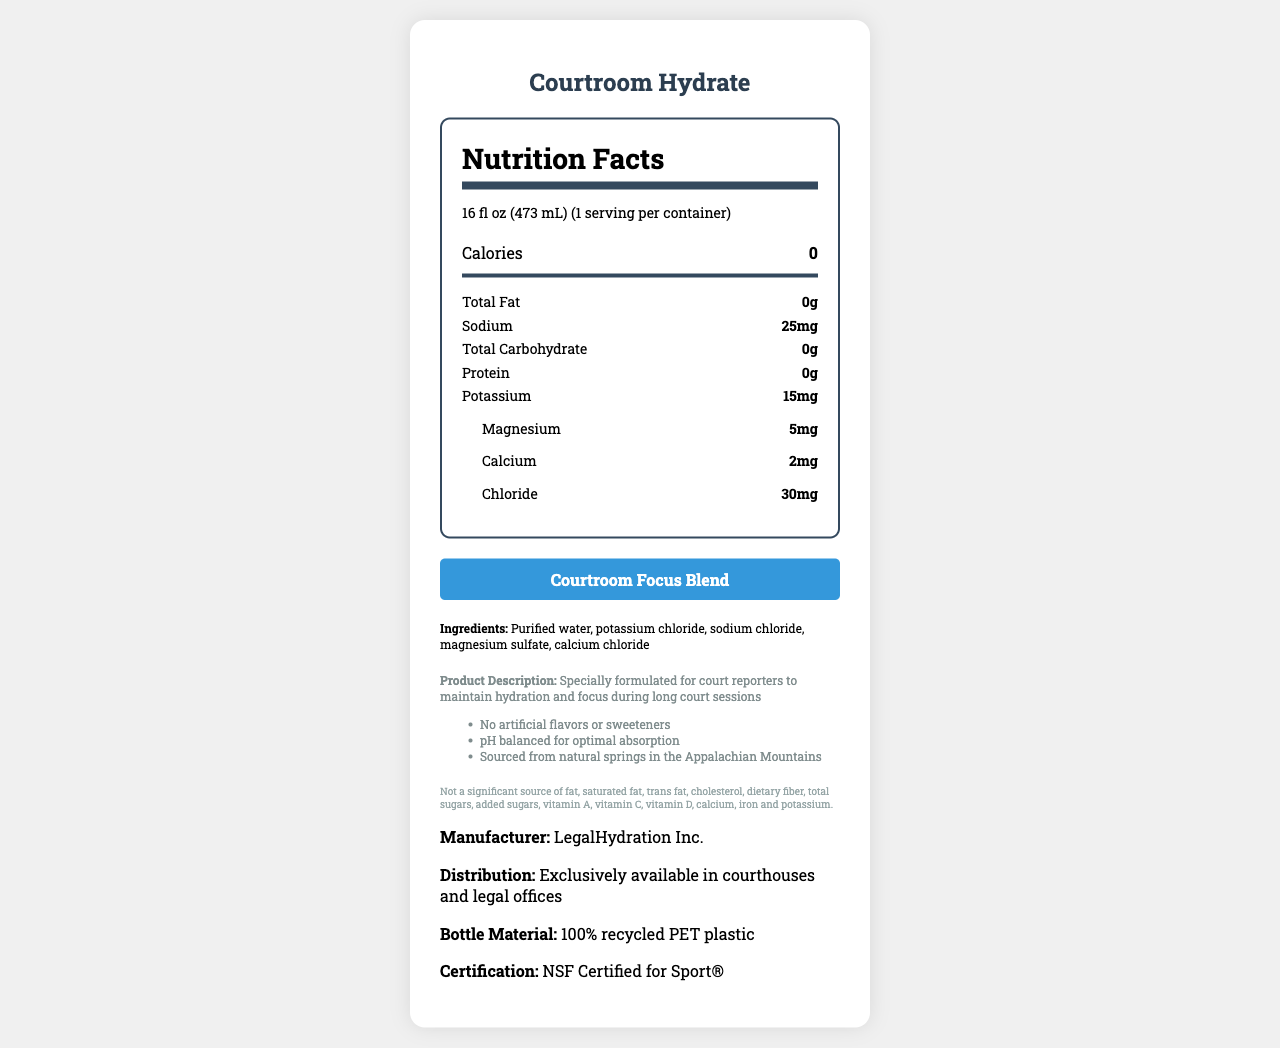what is the serving size of "Courtroom Hydrate"? The document states the serving size as "16 fl oz (473 mL)".
Answer: 16 fl oz (473 mL) How many servings are in one container of "Courtroom Hydrate"? The document mentions that there is 1 serving per container.
Answer: 1 How many calories are in one serving? The Nutrition Facts section reports that there are 0 calories per serving.
Answer: 0 What is the sodium content in one serving? The document lists the sodium content as "25mg" in the Nutrition Facts section.
Answer: 25mg What minerals are included in the "Courtroom Hydrate" electrolyte blend? The document lists potassium, calcium, magnesium, and chloride in the "Courtroom Focus Blend" section.
Answer: potassium, calcium, magnesium, chloride Which ingredient is not found in "Courtroom Hydrate"? A. Magnesium Sulfate B. Sodium Chloride C. High Fructose Corn Syrup D. Potassium Chloride The ingredients list does not include High Fructose Corn Syrup.
Answer: C. High Fructose Corn Syrup What is the source of the water used in "Courtroom Hydrate"? A. Appalachian Mountains B. Rocky Mountains C. Sierra Nevada D. Canadian Rockies The additional information states the water is sourced from natural springs in the Appalachian Mountains.
Answer: A. Appalachian Mountains Are there any artificial flavors or sweeteners in "Courtroom Hydrate"? The document explicitly mentions "No artificial flavors or sweeteners" in the additional information section.
Answer: No Does "Courtroom Hydrate" contain Vitamin D? The Nutrition Facts section lists Vitamin D as "0%".
Answer: No Summarize the purpose and key features of "Courtroom Hydrate". The document is designed to highlight "Courtroom Hydrate" as a specially formulated water for court reporters with features such as hydration support through electrolytes, no artificial additives, and sourcing from natural springs.
Answer: The purpose of "Courtroom Hydrate" is to maintain hydration and focus for court reporters during long sessions. Key features include no calories, a blend of electrolytes, no artificial flavors or sweeteners, pH balanced for optimal absorption, and sourced from the Appalachian Mountains. Is "Courtroom Hydrate" suitable for individuals requiring a significant source of iron? The legal disclaimer clearly states it is not a significant source of iron.
Answer: No What information about the product certification is provided? The document states "NSF Certified for Sport®".
Answer: NSF Certified for Sport® How is the "Courtroom Hydrate" bottle material described? The distribution section mentions the bottle material is made of "100% recycled PET plastic".
Answer: 100% recycled PET plastic Which company manufactures "Courtroom Hydrate"? The manufacturer information lists LegalHydration Inc. as the company responsible.
Answer: LegalHydration Inc. What is the pH balance relevance mentioned in the document? The additional info mentions that the product is "pH balanced for optimal absorption".
Answer: Optimal absorption Who is the target audience for "Courtroom Hydrate"? The product description highlights that it is specially formulated for court reporters to maintain hydration and focus during long sessions.
Answer: Court reporters Does "Courtroom Hydrate" contain any dietary fiber? The legal disclaimer and Nutrition Facts both indicate that it is not a significant source of dietary fiber.
Answer: No What is the primary focus of the nutrition label for "Courtroom Hydrate"? The document focuses on the water's electrolytes and how it supports hydration and focus, targeted towards long court sessions.
Answer: Highlighting electrolytes and hydration How much calcium does "Courtroom Hydrate" provide per serving? The Nutrition Facts section states that the calcium content is 2mg per serving.
Answer: 2mg What is the price of one bottle of "Courtroom Hydrate"? The document does not provide any pricing details.
Answer: Not enough information 